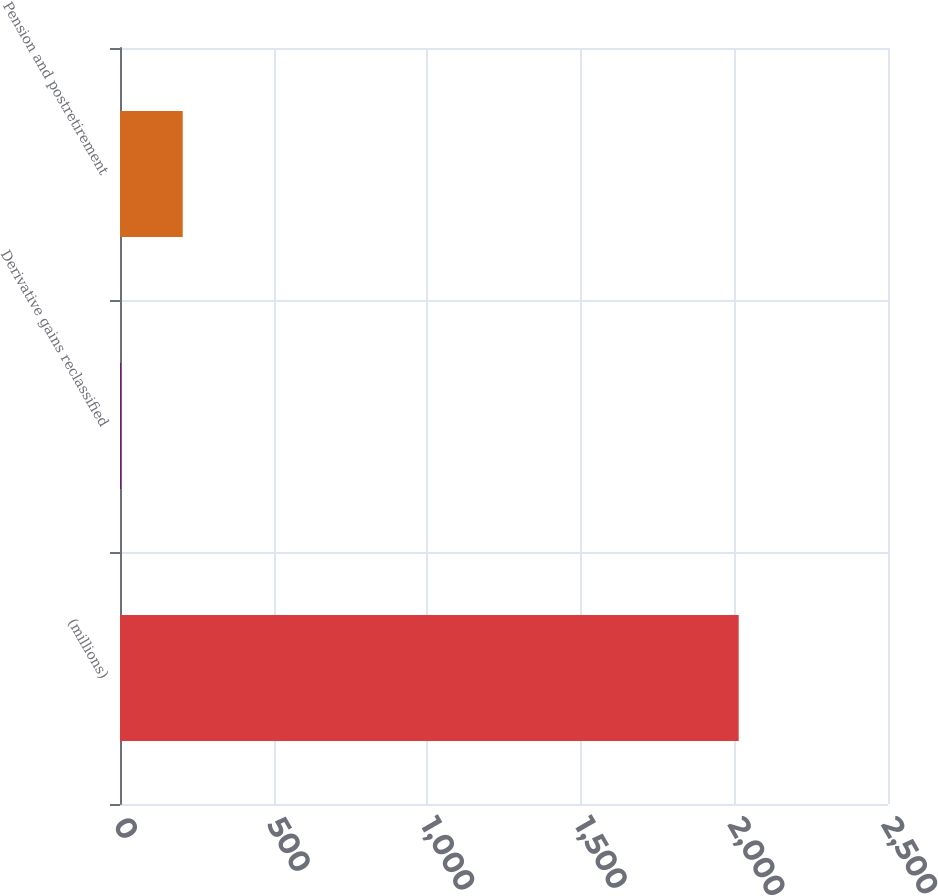<chart> <loc_0><loc_0><loc_500><loc_500><bar_chart><fcel>(millions)<fcel>Derivative gains reclassified<fcel>Pension and postretirement<nl><fcel>2014<fcel>3<fcel>204.1<nl></chart> 